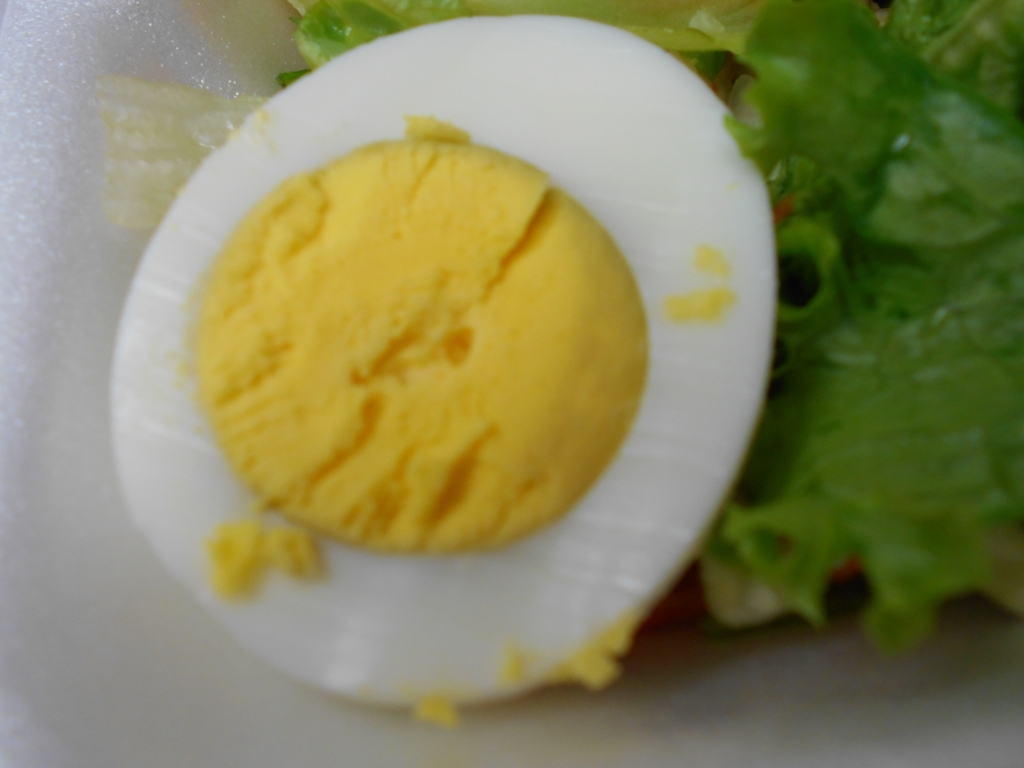What dish is shown in this image? The image appears to display a portion of a salad, specifically featuring a slice of a hard-boiled egg laid on some greens, which might include lettuce. Is this salad a part of a healthy diet? Salads with leafy greens and eggs can be part of a healthy diet, as they provide essential nutrients and proteins. However, the healthiness can vary based on the dressing and other ingredients used. 